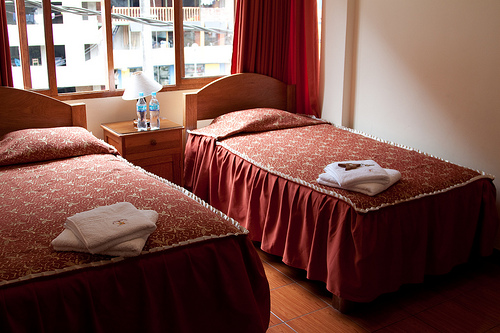Explain how the arrangement of furniture in the room affects its functionality. The strategic placement of twin beds parallel to each other maximizes the available floor space, allowing for free movement. The inclusion of a nightstand between the beds is practical for shared use, enhancing the room's functionality for multiple guests. 